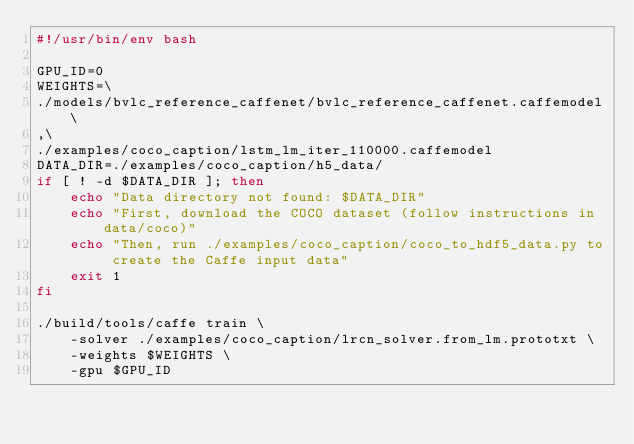Convert code to text. <code><loc_0><loc_0><loc_500><loc_500><_Bash_>#!/usr/bin/env bash

GPU_ID=0
WEIGHTS=\
./models/bvlc_reference_caffenet/bvlc_reference_caffenet.caffemodel\
,\
./examples/coco_caption/lstm_lm_iter_110000.caffemodel
DATA_DIR=./examples/coco_caption/h5_data/
if [ ! -d $DATA_DIR ]; then
    echo "Data directory not found: $DATA_DIR"
    echo "First, download the COCO dataset (follow instructions in data/coco)"
    echo "Then, run ./examples/coco_caption/coco_to_hdf5_data.py to create the Caffe input data"
    exit 1
fi

./build/tools/caffe train \
    -solver ./examples/coco_caption/lrcn_solver.from_lm.prototxt \
    -weights $WEIGHTS \
    -gpu $GPU_ID
</code> 